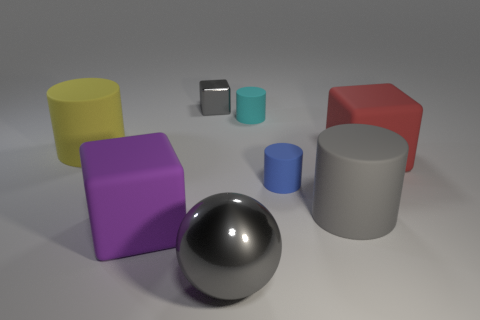How many things are both behind the sphere and in front of the small gray object?
Make the answer very short. 6. There is a gray metallic thing behind the blue rubber thing; is its size the same as the cube that is in front of the blue cylinder?
Provide a succinct answer. No. How many things are either gray metallic objects that are behind the large red object or purple shiny cubes?
Keep it short and to the point. 1. There is a cube that is on the left side of the gray block; what is it made of?
Make the answer very short. Rubber. What material is the big yellow thing?
Give a very brief answer. Rubber. There is a block that is on the right side of the matte cylinder that is behind the big rubber cylinder that is to the left of the big purple matte block; what is its material?
Provide a short and direct response. Rubber. Does the gray cylinder have the same size as the rubber cube that is in front of the large red thing?
Provide a succinct answer. Yes. What number of objects are either matte cylinders left of the big purple block or large matte objects that are left of the gray metallic ball?
Your answer should be compact. 2. There is a small matte object that is to the left of the blue matte thing; what color is it?
Your answer should be very brief. Cyan. Is there a small cyan matte thing to the left of the tiny matte cylinder behind the red rubber thing?
Offer a terse response. No. 